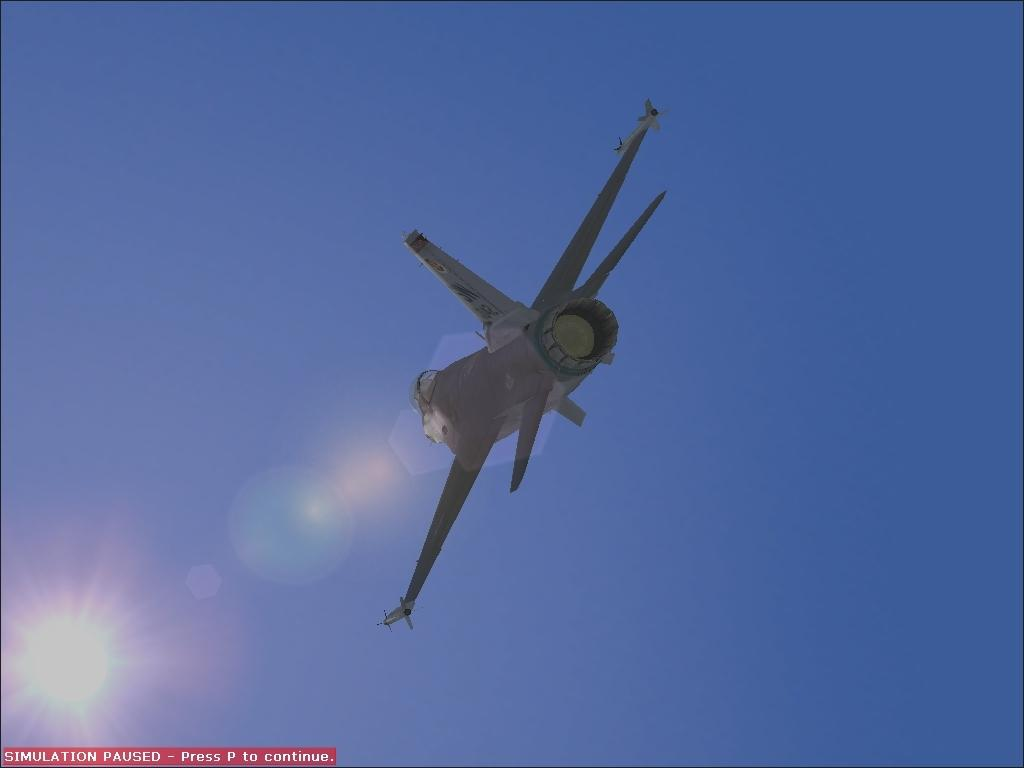What is the main subject of the image? The main subject of the image is an aircraft. What can be seen in the background of the image? The sky is visible in the image, and there is sunlight visible in the background. Is there any text present in the image? Yes, there is text in the bottom left of the image. What is the price of the control connection in the image? There is no control connection or price mentioned in the image. 